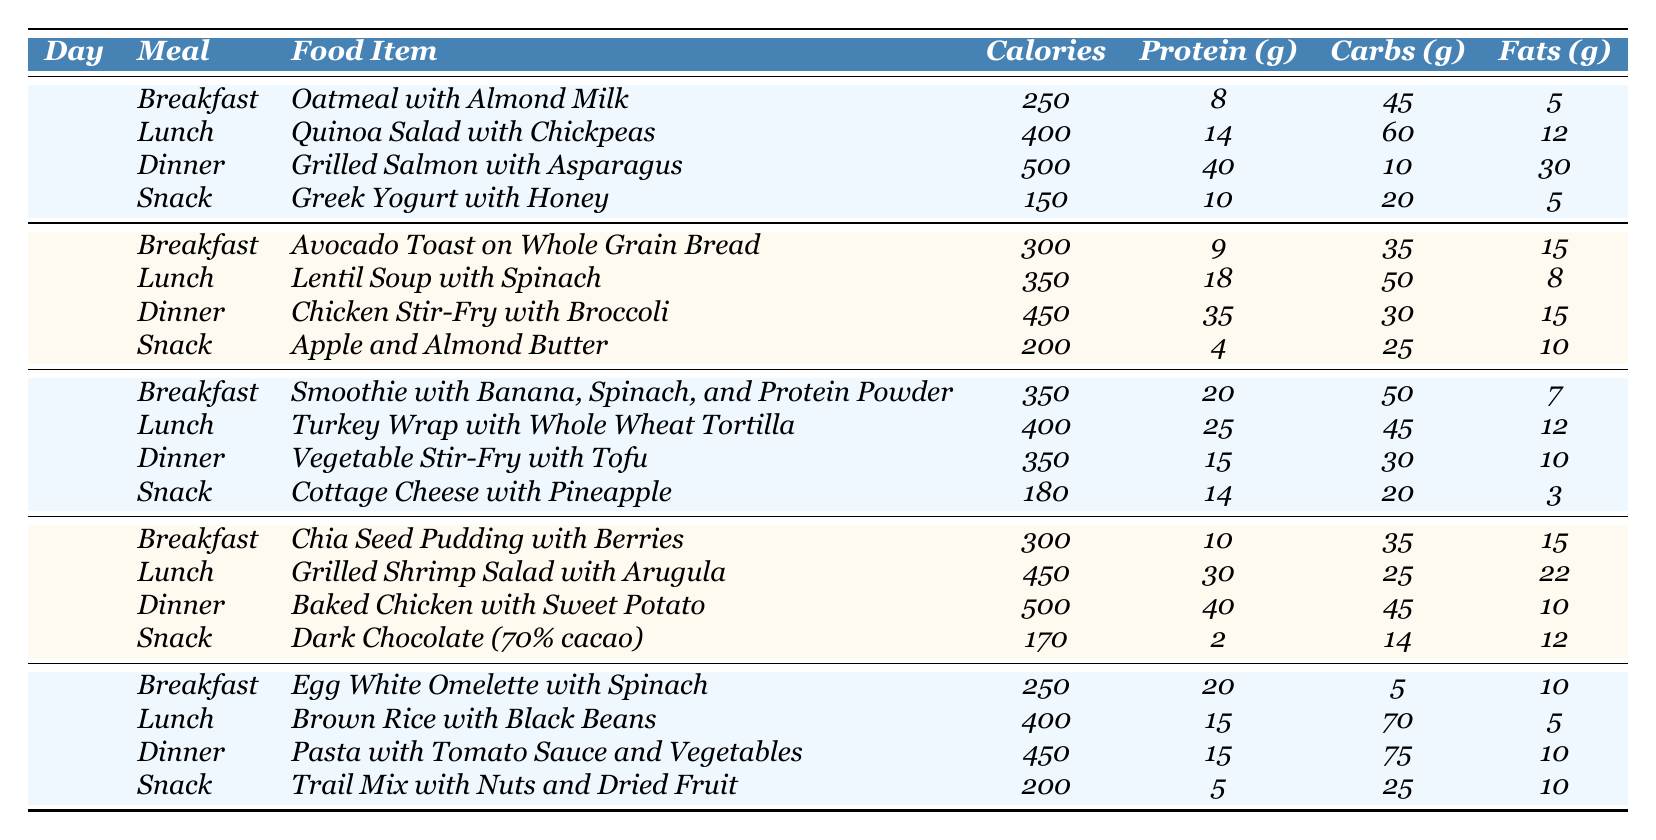What was the total calorie intake on Day 1? To find the total calorie intake for Day 1, I need to add the calories from each meal: Breakfast (250) + Lunch (400) + Dinner (500) + Snack (150) = 1300 calories.
Answer: 1300 What was the food item with the highest protein content on Day 3? On Day 3, the food items and their protein content are: Smoothie (20g), Turkey Wrap (25g), Vegetable Stir-Fry (15g), Cottage Cheese (14g). The Turkey Wrap has the highest protein content at 25g.
Answer: Turkey Wrap with Whole Wheat Tortilla What is the average carbohydrate intake for Day 2? The carbohydrate intakes for Day 2 are: Breakfast (35g) + Lunch (50g) + Dinner (30g) + Snack (25g) = 140g. To find the average, divide by the number of meals, which is 4: 140g / 4 = 35g.
Answer: 35g Was the total fat intake greater on Day 4 than on Day 5? The total fat intake for Day 4 is calculated as follows: Breakfast (15g) + Lunch (22g) + Dinner (10g) + Snack (12g) = 59g. For Day 5, it is Breakfast (10g) + Lunch (5g) + Dinner (10g) + Snack (10g) = 35g. Since 59g (Day 4) is greater than 35g (Day 5), the statement is true.
Answer: Yes What meal had the lowest calorie count throughout the month? Reviewing the calorie counts for all meals in the month, the lowest is from the Greek Yogurt with Honey at 150 calories on Day 1, Snack.
Answer: Greek Yogurt with Honey What is the total protein intake for Lunch across all days? For Lunch, the protein amounts are: Day 1 (14g) + Day 2 (18g) + Day 3 (25g) + Day 4 (30g) + Day 5 (15g) = 102g total protein intake for all Lunches.
Answer: 102g Which meal had the highest fat content on Day 2? On Day 2, the fat contents for each meal are: Breakfast (15g), Lunch (8g), Dinner (15g), Snack (10g). Both the Chicken Stir-Fry and Avocado Toast have the highest fat, both at 15g.
Answer: Chicken Stir-Fry with Broccoli / Avocado Toast on Whole Grain Bread What was the average calorie intake for all snacks in the month? The calorie intake for snacks is as follows: Day 1 (150) + Day 2 (200) + Day 3 (180) + Day 4 (170) + Day 5 (200) = 1100 calories. The average is 1100 / 5 = 220 calories.
Answer: 220 calories Did the protein content at Dinner exceed 40g on any day? On reviewing each day's Dinner protein content: Day 1 (40g), Day 2 (35g), Day 3 (15g), Day 4 (40g), Day 5 (15g). The highest was 40g, thus it did not exceed 40g on any day.
Answer: No Which day had the highest total calorie intake? Calculating the total calories for each day: Day 1 (1300), Day 2 (1300), Day 3 (1300), Day 4 (1420), Day 5 (1300). Day 4 had the highest at 1420 calories.
Answer: Day 4 